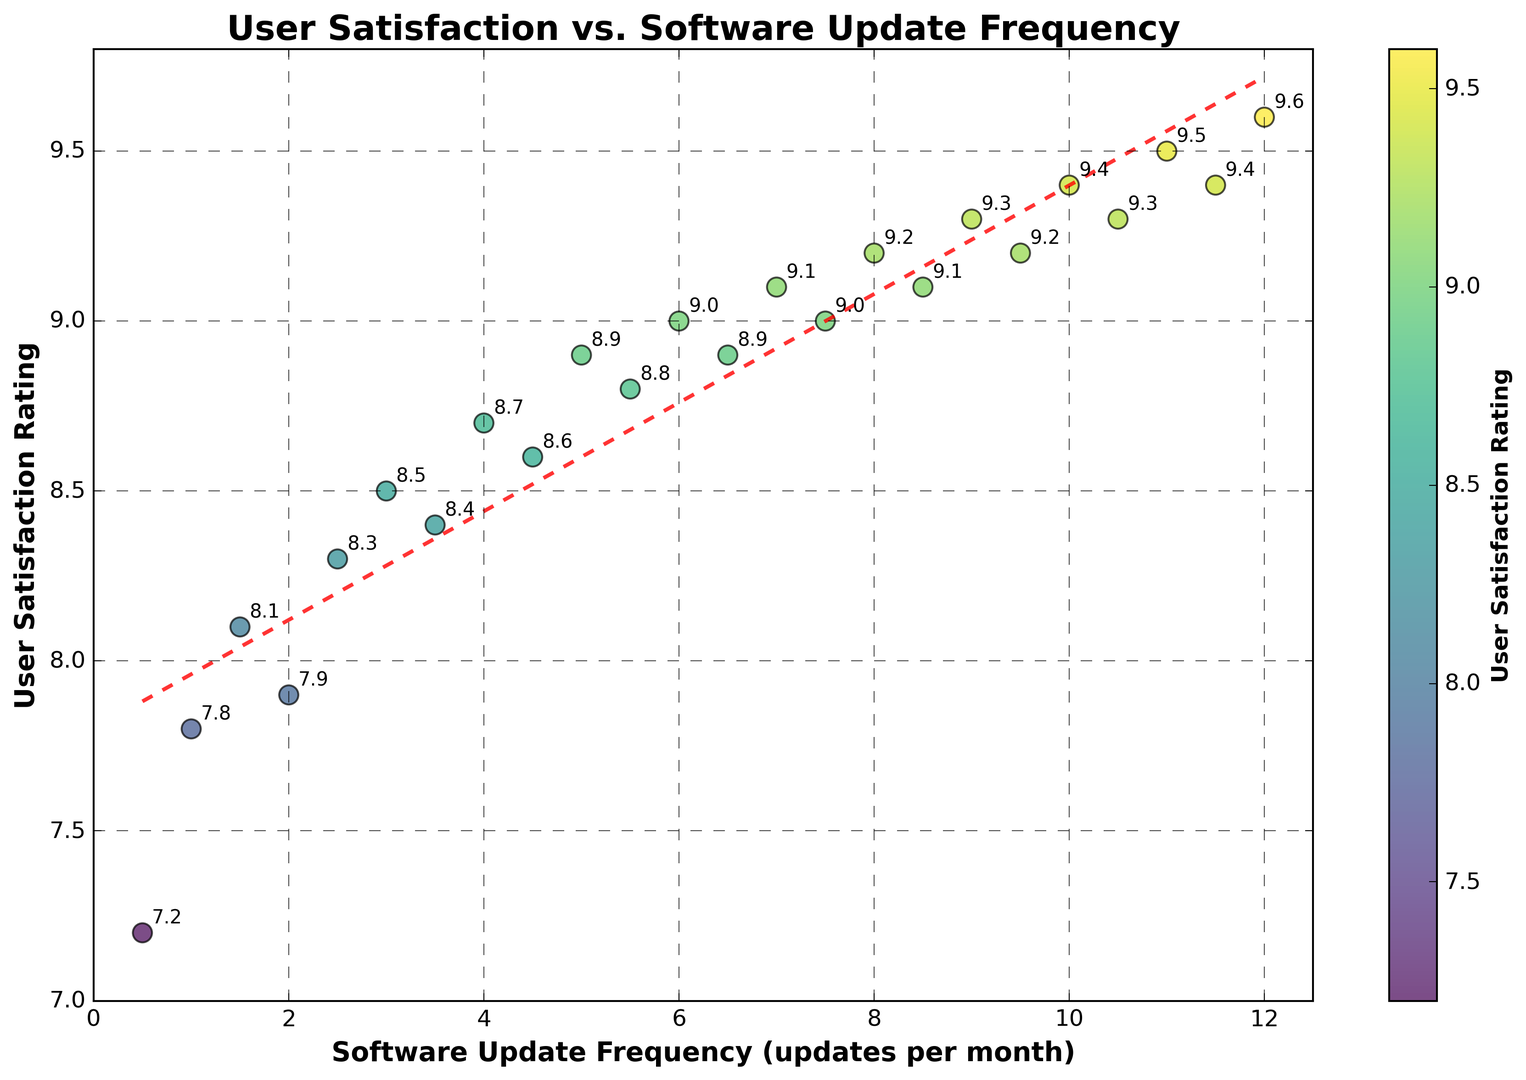What trend do you see between user satisfaction rating and software update frequency? As the software update frequency increases, the user satisfaction rating also tends to increase, suggesting a positive correlation.
Answer: Positive correlation What is the user satisfaction rating when the software update frequency is 6 updates per month? Look at the scatter plot point where the update frequency is 6. The corresponding satisfaction rating is 9.0.
Answer: 9.0 Which data point represents the highest user satisfaction rating and what is the corresponding software update frequency? The highest satisfaction rating is 9.6, which corresponds to a software update frequency of 12 updates per month.
Answer: 12 updates per month, 9.6 satisfaction rating Compare the user satisfaction ratings for 1 update per month and 7 updates per month. Which is higher? Find the scatter plot points for 1 update per month and 7 updates per month. Compare the satisfaction ratings; 1 update per month has a rating of 7.8 while 7 updates per month has a rating of 9.1.
Answer: 7 updates per month has a higher rating What is the average user satisfaction rating for update frequencies greater than or equal to 5 updates per month? Identify the ratings for update frequencies 5, 5.5, 6, 6.5, 7, 7.5, 8, 8.5, 9, 9.5, 10, 10.5, 11, 11.5, 12. Sum these ratings (8.9 + 8.8 + 9.0 + 8.9 + 9.1 + 9.0 + 9.2 + 9.1 + 9.3 + 9.2 + 9.4 + 9.3 + 9.5 + 9.4 + 9.6 = 137.7). Divide by the number of terms (15). The average is 137.7 / 15 = 9.18.
Answer: 9.18 What color are the data points with the highest user satisfaction ratings? The color of the data points corresponds to user satisfaction rating using a viridis color map. The highest ratings are colored greenish-yellow to yellow.
Answer: Greenish-yellow to yellow What is the slope of the trendline fitted to the data? The trendline is shown as a red dashed line. The equation of the trendline gives the slope, which is the coefficient of x in the linear equation represented by the line. As per the visual reference, the slope shows a positive value indicating an increase in satisfaction with an increase in updates.
Answer: Positive slope How does the user satisfaction rating change between 4 and 4.5 updates per month? Look at the points corresponding to 4 and 4.5 updates per month. The ratings are 8.7 at 4 updates and 8.6 at 4.5 updates, indicating a slight decrease in satisfaction.
Answer: Slight decrease Between which update frequencies does the greatest increase in user satisfaction rating occur? Compare the differences in satisfaction ratings between consecutive update frequencies. The largest difference visually or by calculation is between 2.5 (8.3) and 3 (8.5), showing an increase of 0.2.
Answer: Between 2.5 and 3 updates per month What is the range of user satisfaction ratings? Identify the minimum and maximum user satisfaction ratings from the data points. The minimum rating is 7.2, and the maximum is 9.6. The range is 9.6 - 7.2 = 2.4.
Answer: 2.4 